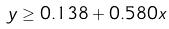<formula> <loc_0><loc_0><loc_500><loc_500>y \geq 0 . 1 3 8 + 0 . 5 8 0 x</formula> 